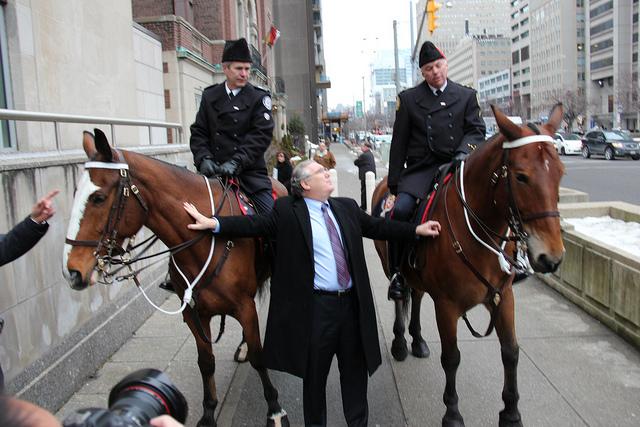Is it a nice summer day outside?
Short answer required. No. How many officers are riding horses?
Write a very short answer. 2. How many men are there?
Give a very brief answer. 3. 